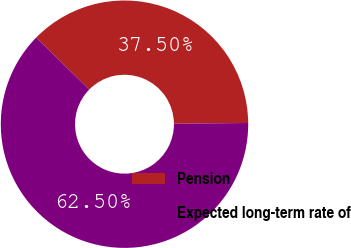Convert chart to OTSL. <chart><loc_0><loc_0><loc_500><loc_500><pie_chart><fcel>Pension<fcel>Expected long-term rate of<nl><fcel>37.5%<fcel>62.5%<nl></chart> 